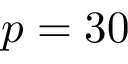<formula> <loc_0><loc_0><loc_500><loc_500>p = 3 0</formula> 